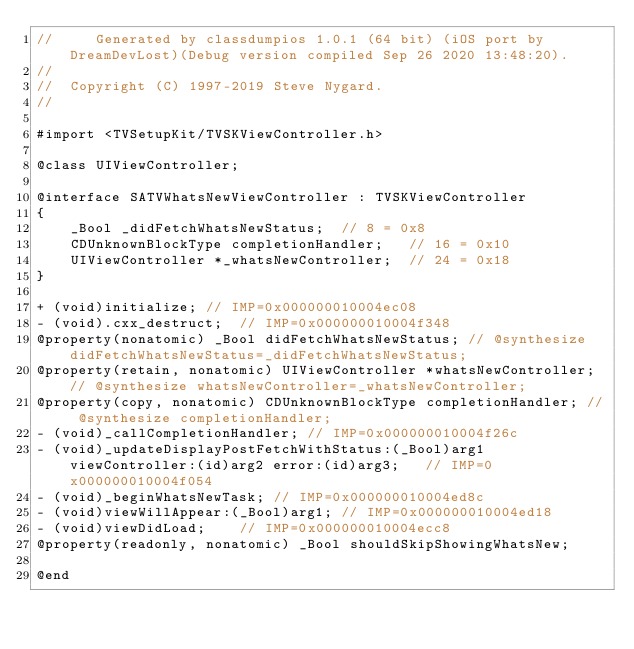Convert code to text. <code><loc_0><loc_0><loc_500><loc_500><_C_>//     Generated by classdumpios 1.0.1 (64 bit) (iOS port by DreamDevLost)(Debug version compiled Sep 26 2020 13:48:20).
//
//  Copyright (C) 1997-2019 Steve Nygard.
//

#import <TVSetupKit/TVSKViewController.h>

@class UIViewController;

@interface SATVWhatsNewViewController : TVSKViewController
{
    _Bool _didFetchWhatsNewStatus;	// 8 = 0x8
    CDUnknownBlockType completionHandler;	// 16 = 0x10
    UIViewController *_whatsNewController;	// 24 = 0x18
}

+ (void)initialize;	// IMP=0x000000010004ec08
- (void).cxx_destruct;	// IMP=0x000000010004f348
@property(nonatomic) _Bool didFetchWhatsNewStatus; // @synthesize didFetchWhatsNewStatus=_didFetchWhatsNewStatus;
@property(retain, nonatomic) UIViewController *whatsNewController; // @synthesize whatsNewController=_whatsNewController;
@property(copy, nonatomic) CDUnknownBlockType completionHandler; // @synthesize completionHandler;
- (void)_callCompletionHandler;	// IMP=0x000000010004f26c
- (void)_updateDisplayPostFetchWithStatus:(_Bool)arg1 viewController:(id)arg2 error:(id)arg3;	// IMP=0x000000010004f054
- (void)_beginWhatsNewTask;	// IMP=0x000000010004ed8c
- (void)viewWillAppear:(_Bool)arg1;	// IMP=0x000000010004ed18
- (void)viewDidLoad;	// IMP=0x000000010004ecc8
@property(readonly, nonatomic) _Bool shouldSkipShowingWhatsNew;

@end

</code> 